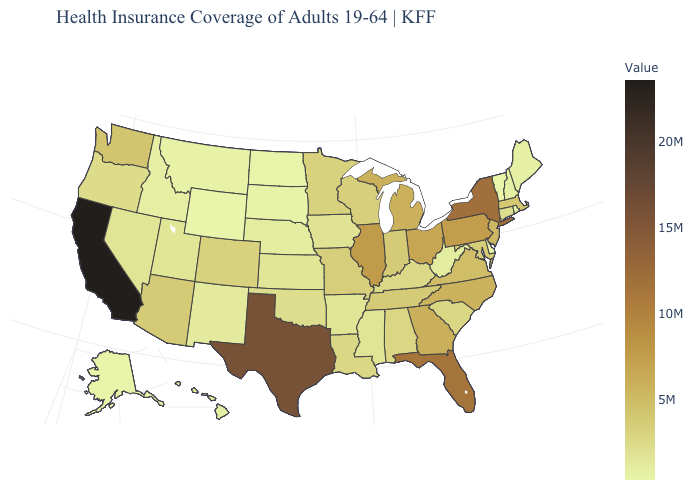Which states have the lowest value in the MidWest?
Short answer required. North Dakota. Among the states that border North Dakota , does Minnesota have the highest value?
Concise answer only. Yes. Does Maryland have the highest value in the South?
Concise answer only. No. Which states have the highest value in the USA?
Concise answer only. California. Among the states that border Idaho , which have the lowest value?
Quick response, please. Wyoming. 